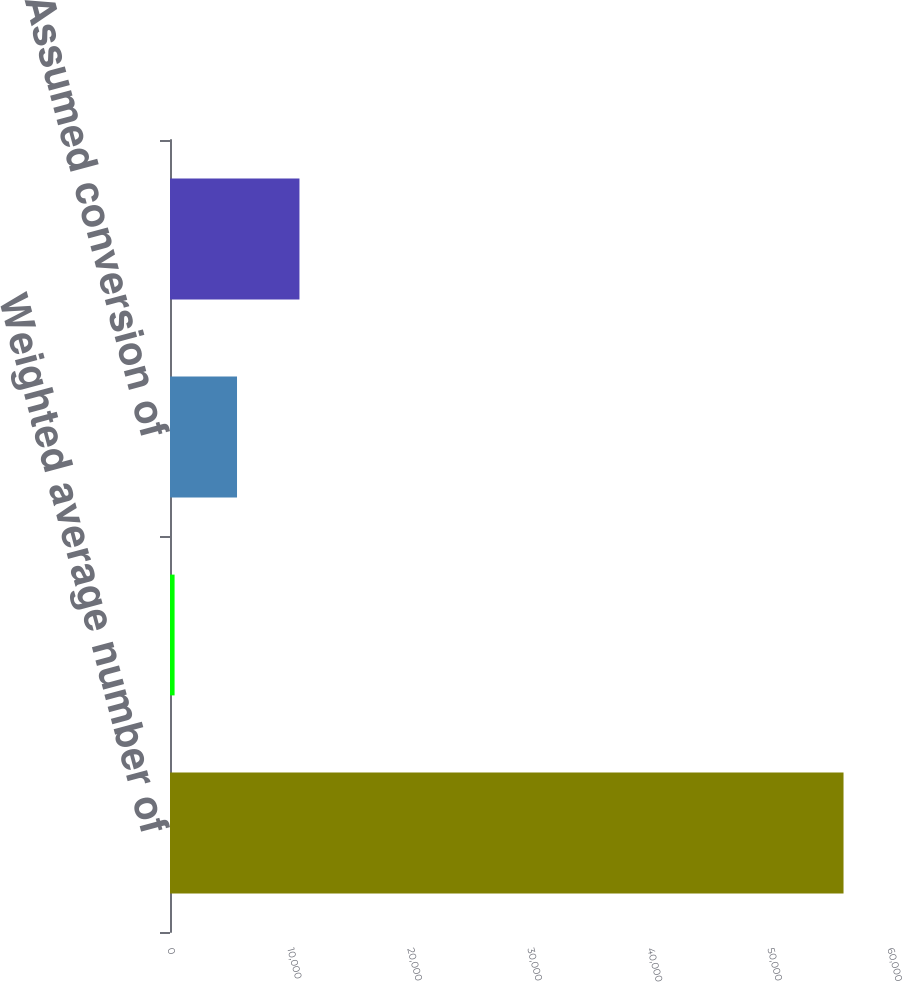<chart> <loc_0><loc_0><loc_500><loc_500><bar_chart><fcel>Weighted average number of<fcel>Weighted average dilutive<fcel>Assumed conversion of<fcel>Anti-dilutive potential common<nl><fcel>56127.1<fcel>382<fcel>5585.1<fcel>10788.2<nl></chart> 